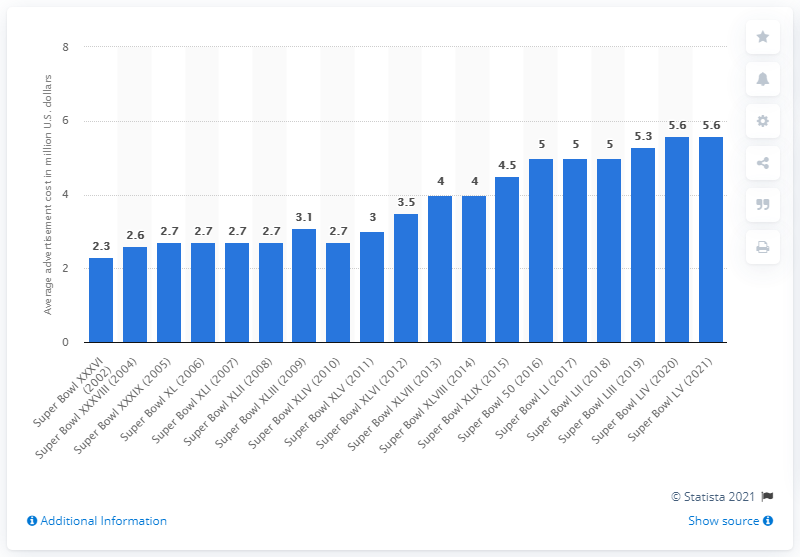Outline some significant characteristics in this image. The cost for advertisers to air a 30-second commercial during the 2021 Super Bowl was $5.6 million. In 2016, a 30-second TV ad cost an average of 5.6 cents. 